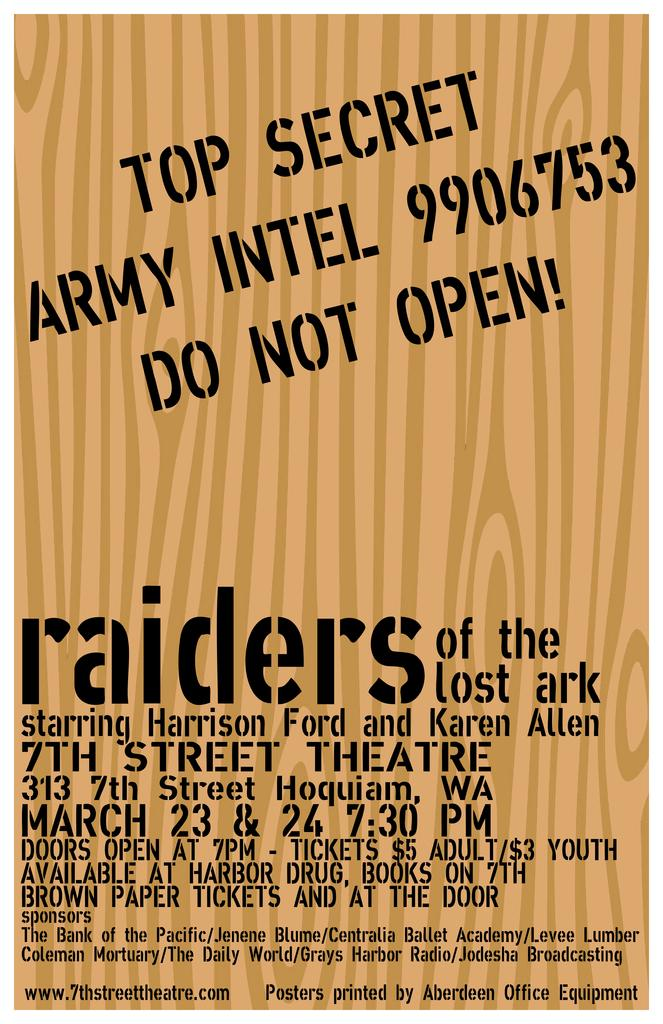<image>
Create a compact narrative representing the image presented. An advertisement is for a performance by raiders of the lost ark . 